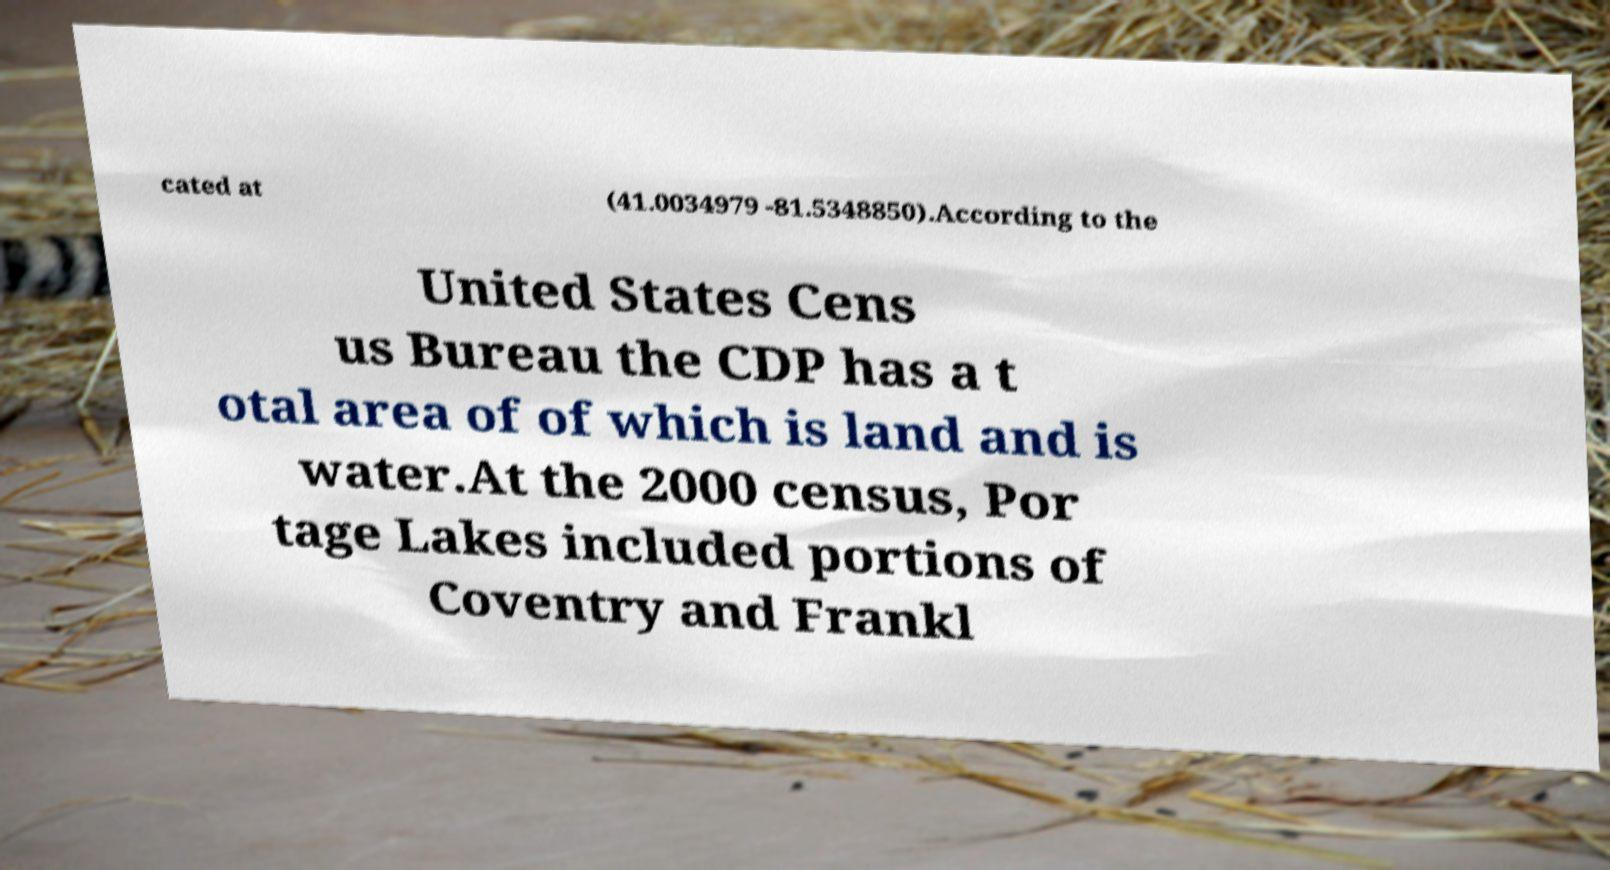Can you read and provide the text displayed in the image?This photo seems to have some interesting text. Can you extract and type it out for me? cated at (41.0034979 -81.5348850).According to the United States Cens us Bureau the CDP has a t otal area of of which is land and is water.At the 2000 census, Por tage Lakes included portions of Coventry and Frankl 